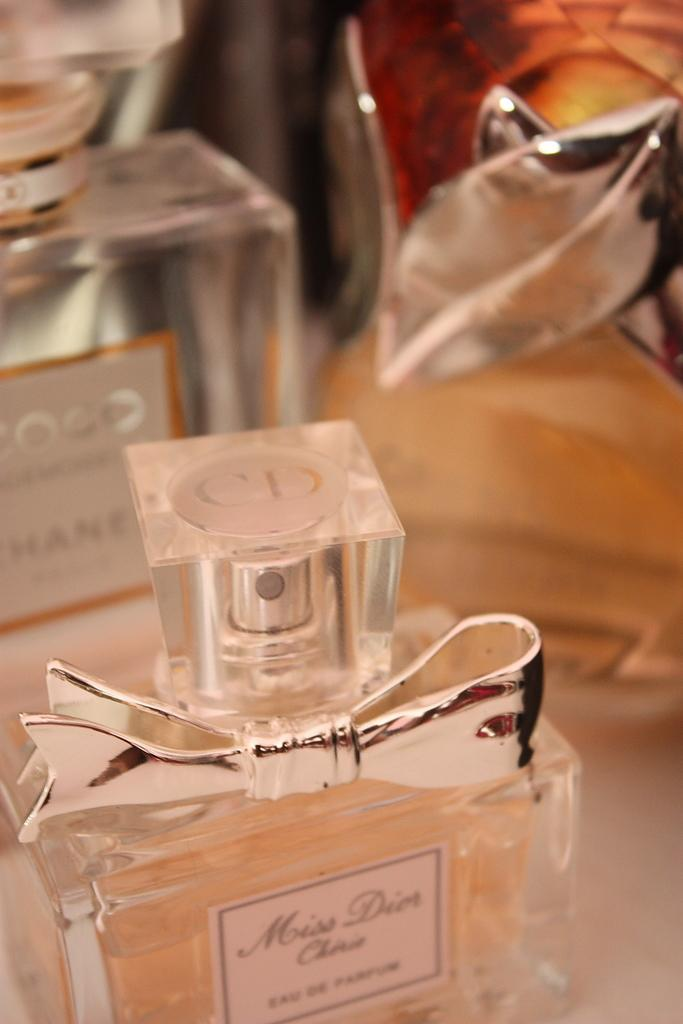<image>
Create a compact narrative representing the image presented. Bottle of Miss Dior perfume with a bow on it. 